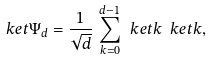Convert formula to latex. <formula><loc_0><loc_0><loc_500><loc_500>\ k e t { \Psi _ { d } } = \frac { 1 } { \sqrt { d } } \, \sum _ { k = 0 } ^ { d - 1 } \ k e t { k } \ k e t { k } ,</formula> 